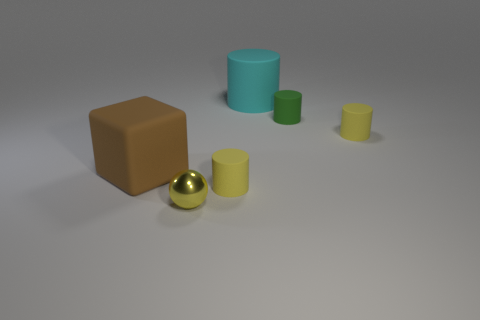Is there any other thing that has the same shape as the large brown rubber object?
Keep it short and to the point. No. There is a big cyan object that is the same material as the green object; what shape is it?
Your response must be concise. Cylinder. Are there the same number of tiny yellow matte things that are behind the brown cube and big yellow blocks?
Make the answer very short. No. Are the cylinder to the right of the tiny green object and the yellow cylinder that is in front of the large brown cube made of the same material?
Offer a terse response. Yes. There is a matte object that is behind the small green cylinder that is to the right of the yellow metal sphere; what is its shape?
Ensure brevity in your answer.  Cylinder. There is a large object that is the same material as the cyan cylinder; what color is it?
Give a very brief answer. Brown. Is the color of the ball the same as the big cylinder?
Provide a short and direct response. No. The brown rubber object that is the same size as the cyan matte cylinder is what shape?
Provide a short and direct response. Cube. How big is the matte block?
Your answer should be compact. Large. There is a yellow rubber thing left of the cyan object; is its size the same as the brown block that is to the left of the yellow shiny sphere?
Ensure brevity in your answer.  No. 